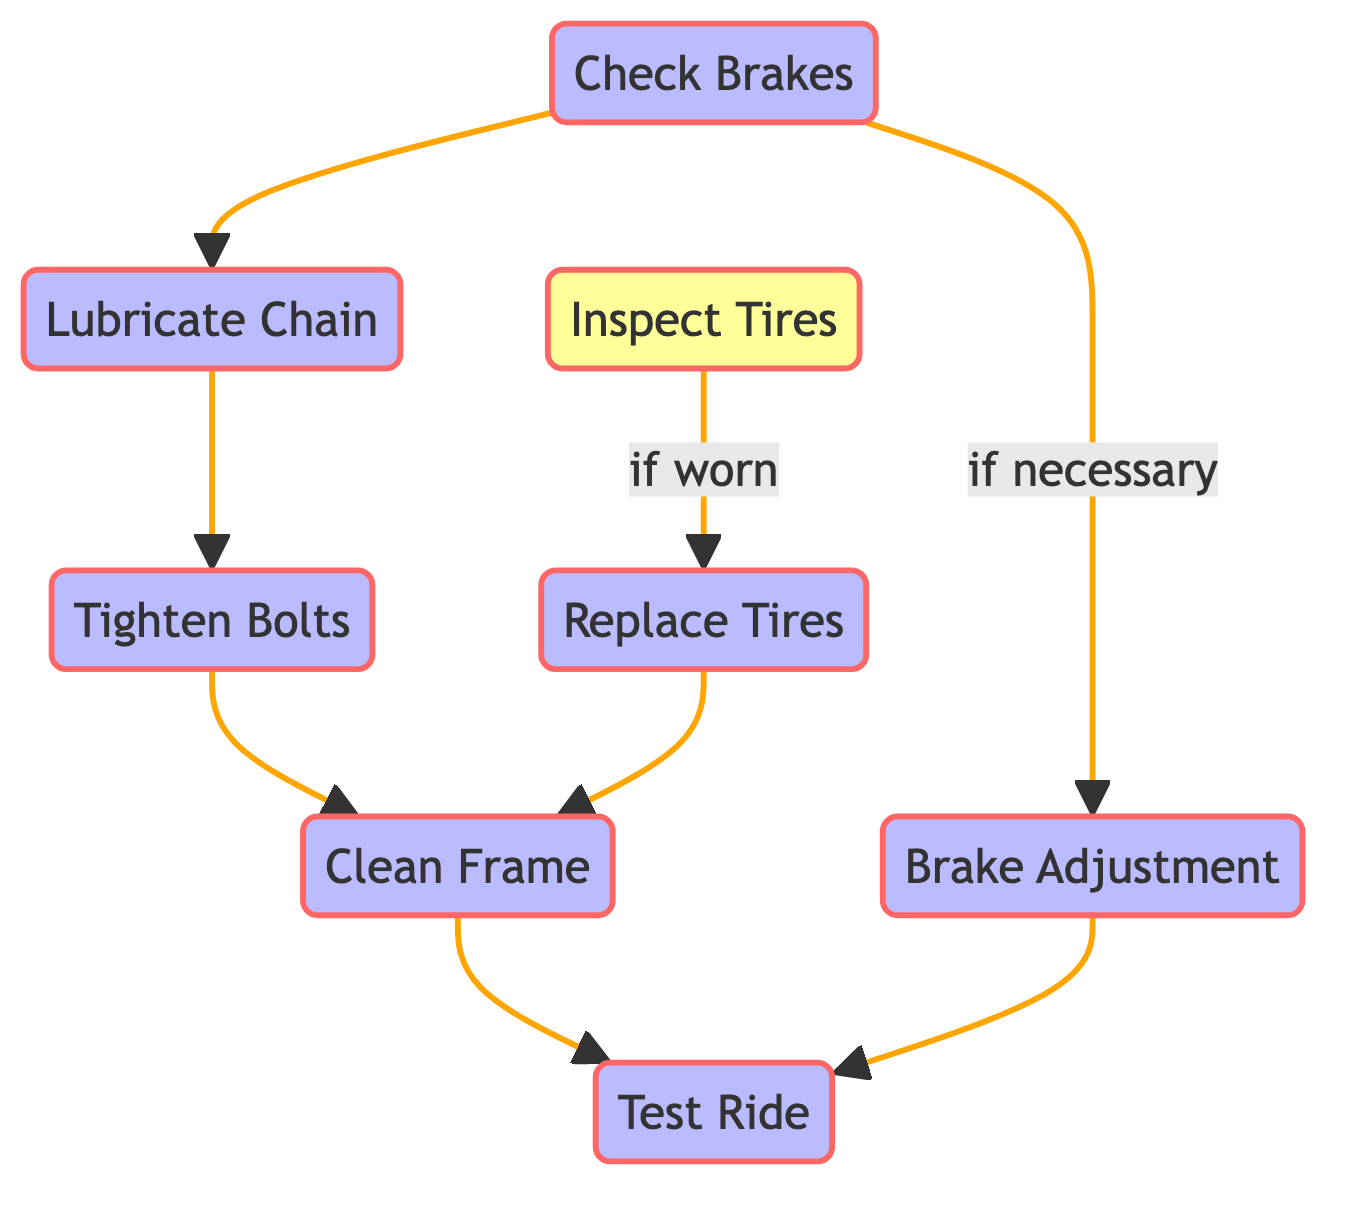What is the first step in the bike maintenance process? The first step shown in the diagram is "Check Brakes." It is positioned at the start of the directed flow and directly leads to other steps.
Answer: Check Brakes How many nodes are there in the diagram? The diagram contains a total of 8 nodes representing different steps and processes in bike maintenance.
Answer: 8 What step follows "Tighten Bolts"? After "Tighten Bolts," the next step in the flow is "Clean Frame." This is shown in the diagram as a direct connection from "Tighten Bolts" to "Clean Frame."
Answer: Clean Frame What happens if the tires are worn? If the tires are worn as indicated in the diagram under "Inspect Tires," the next action is to "Replace Tires." This is shown as a conditional path leading from "Inspect Tires" to "Replace Tires."
Answer: Replace Tires Which nodes lead to "Test Ride"? The nodes leading to "Test Ride" are "Brake Adjustment" and "Clean Frame." Both nodes have directed edges leading to "Test Ride" in the diagram.
Answer: Brake Adjustment, Clean Frame What is the relationship between "Check Brakes" and "Brake Adjustment"? The relationship is conditional, as indicated in the diagram. If the brakes need adjustment after being checked, the process moves to "Brake Adjustment." This is explicitly labeled as "if necessary" in the directed graph.
Answer: if necessary Which step involves applying lubricant? The step that involves applying lubricant is "Lubricate Chain." This is part of the maintenance process to reduce friction and prevent rust, as indicated in the node description.
Answer: Lubricate Chain How many decision points are in the diagram? There is one decision point in the diagram, which is "Inspect Tires." It leads to a conditional step based on the condition of the tires being worn or not.
Answer: 1 What is the final step in the maintenance process? The final step in the maintenance process, as shown in the diagram, is "Test Ride." This node is positioned at the end of the flow.
Answer: Test Ride 